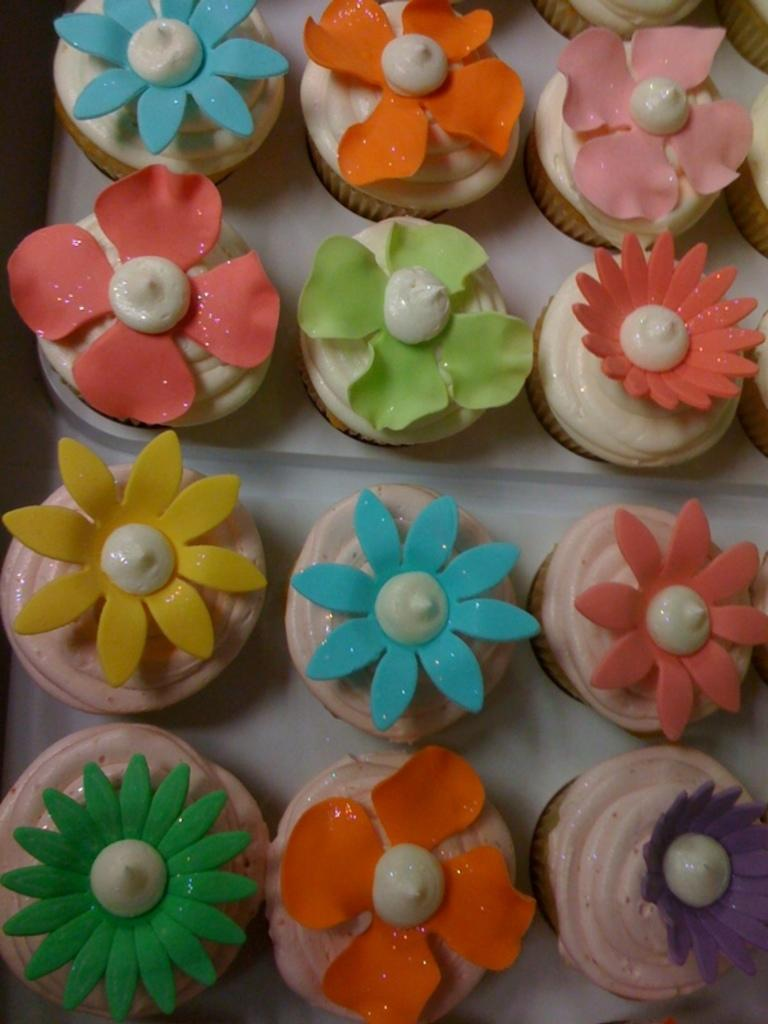What type of food is present on the plates in the image? There are cupcakes in the plates in the image. What is the chance of winning a screw in the image? There is no mention of winning or screws in the image. 